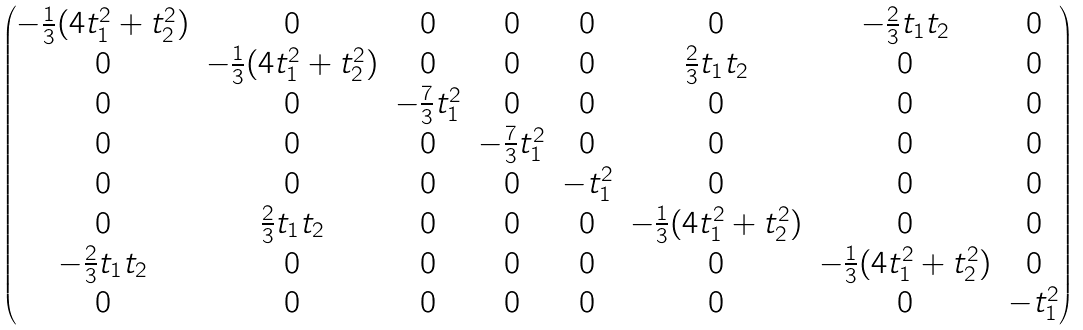<formula> <loc_0><loc_0><loc_500><loc_500>\begin{pmatrix} - \frac { 1 } { 3 } ( 4 t _ { 1 } ^ { 2 } + t _ { 2 } ^ { 2 } ) & 0 & 0 & 0 & 0 & 0 & - \frac { 2 } { 3 } t _ { 1 } t _ { 2 } & 0 \\ 0 & - \frac { 1 } { 3 } ( 4 t _ { 1 } ^ { 2 } + t _ { 2 } ^ { 2 } ) & 0 & 0 & 0 & \frac { 2 } { 3 } t _ { 1 } t _ { 2 } & 0 & 0 \\ 0 & 0 & - \frac { 7 } { 3 } t _ { 1 } ^ { 2 } & 0 & 0 & 0 & 0 & 0 \\ 0 & 0 & 0 & - \frac { 7 } { 3 } t _ { 1 } ^ { 2 } & 0 & 0 & 0 & 0 \\ 0 & 0 & 0 & 0 & - t _ { 1 } ^ { 2 } & 0 & 0 & 0 \\ 0 & \frac { 2 } { 3 } t _ { 1 } t _ { 2 } & 0 & 0 & 0 & - \frac { 1 } { 3 } ( 4 t _ { 1 } ^ { 2 } + t _ { 2 } ^ { 2 } ) & 0 & 0 \\ - \frac { 2 } { 3 } t _ { 1 } t _ { 2 } & 0 & 0 & 0 & 0 & 0 & - \frac { 1 } { 3 } ( 4 t _ { 1 } ^ { 2 } + t _ { 2 } ^ { 2 } ) & 0 \\ 0 & 0 & 0 & 0 & 0 & 0 & 0 & - t _ { 1 } ^ { 2 } \end{pmatrix}</formula> 